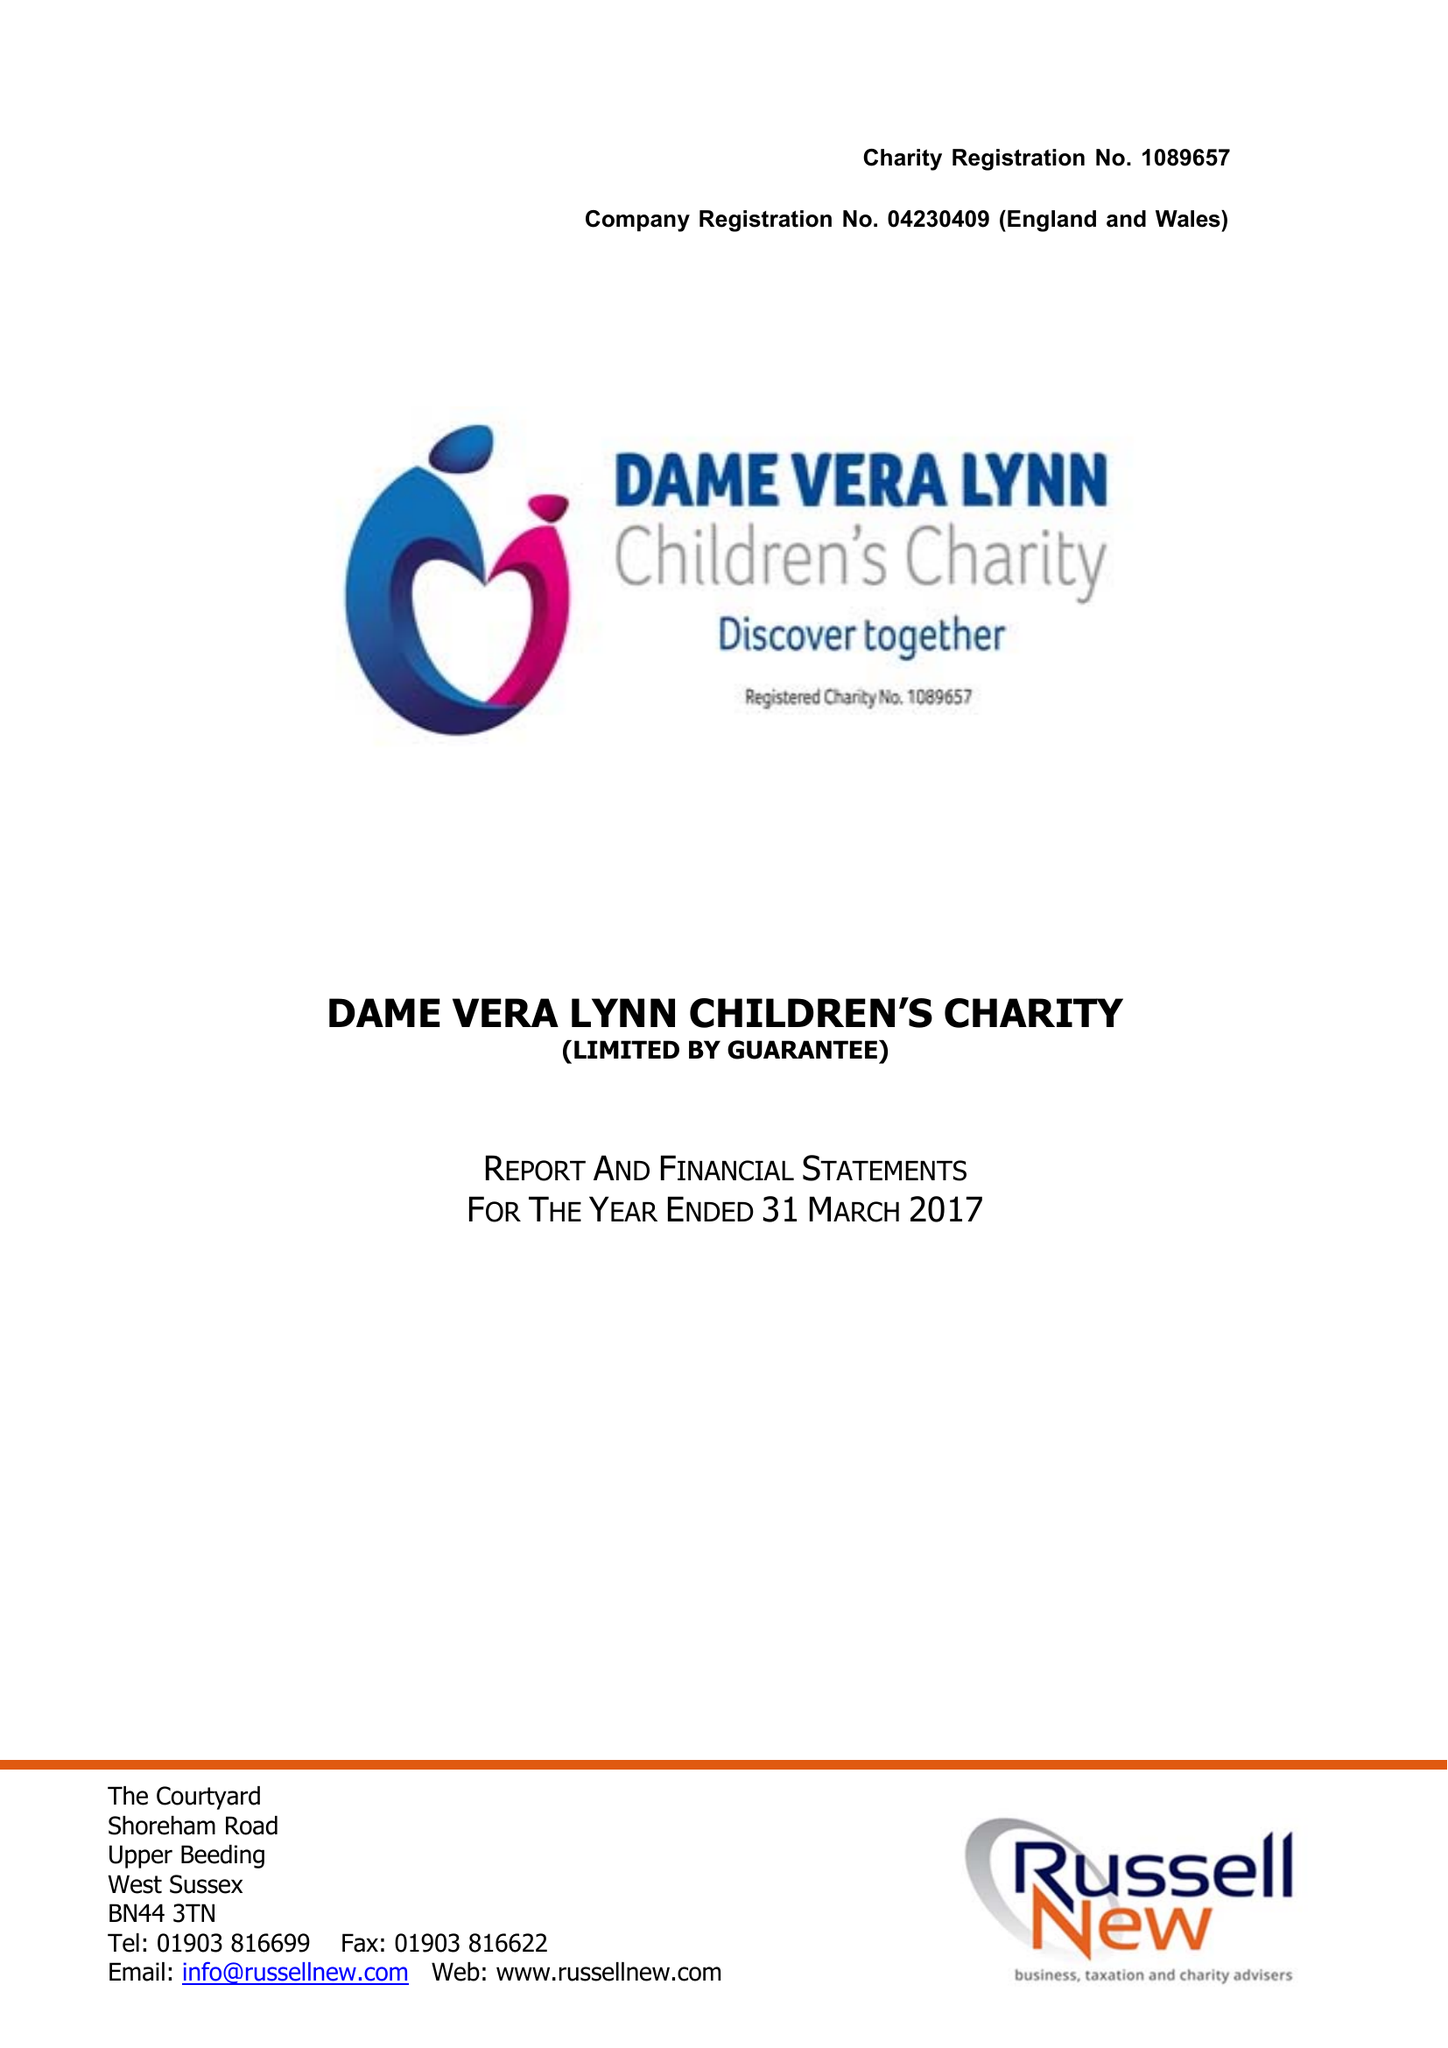What is the value for the report_date?
Answer the question using a single word or phrase. 2017-03-31 